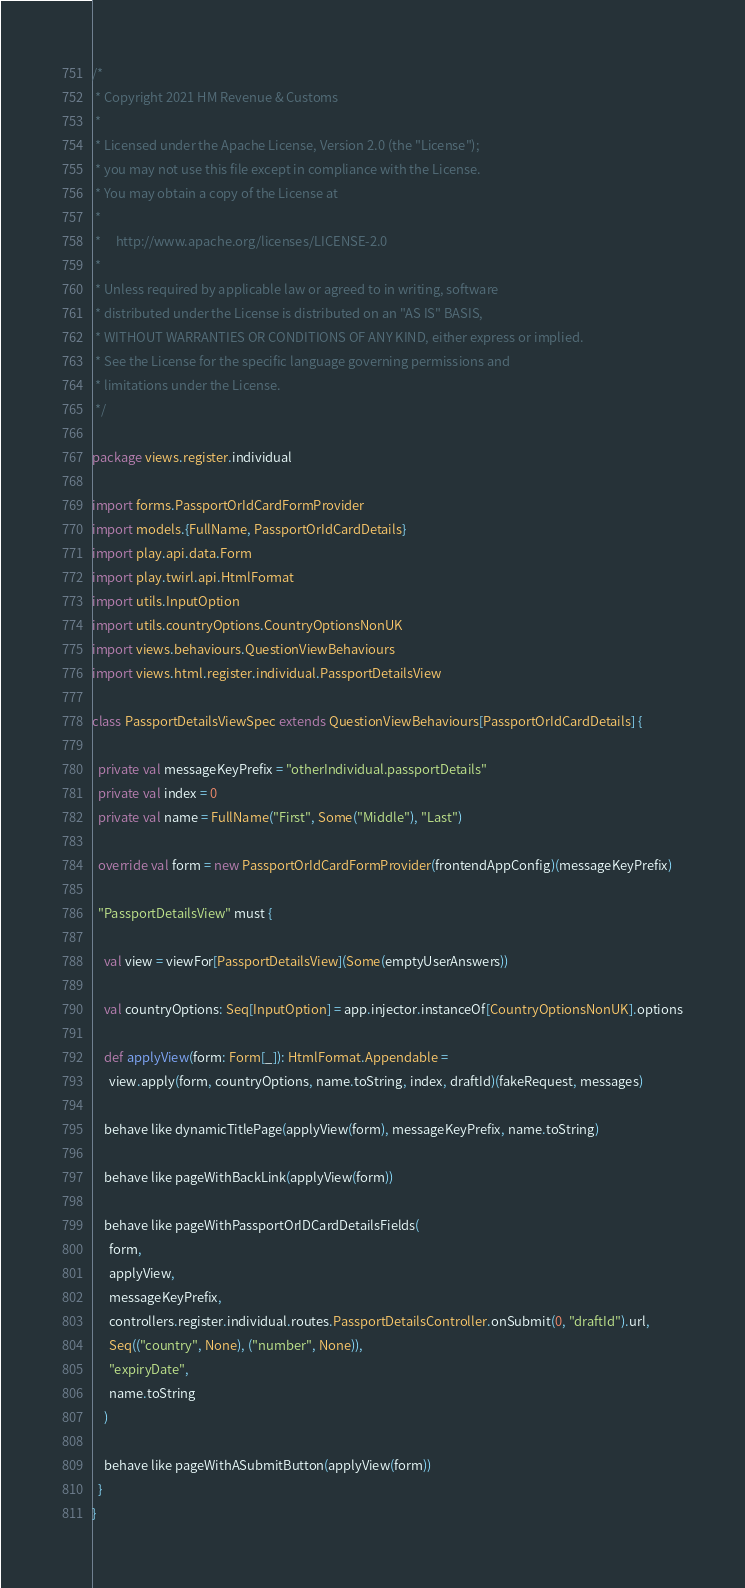<code> <loc_0><loc_0><loc_500><loc_500><_Scala_>/*
 * Copyright 2021 HM Revenue & Customs
 *
 * Licensed under the Apache License, Version 2.0 (the "License");
 * you may not use this file except in compliance with the License.
 * You may obtain a copy of the License at
 *
 *     http://www.apache.org/licenses/LICENSE-2.0
 *
 * Unless required by applicable law or agreed to in writing, software
 * distributed under the License is distributed on an "AS IS" BASIS,
 * WITHOUT WARRANTIES OR CONDITIONS OF ANY KIND, either express or implied.
 * See the License for the specific language governing permissions and
 * limitations under the License.
 */

package views.register.individual

import forms.PassportOrIdCardFormProvider
import models.{FullName, PassportOrIdCardDetails}
import play.api.data.Form
import play.twirl.api.HtmlFormat
import utils.InputOption
import utils.countryOptions.CountryOptionsNonUK
import views.behaviours.QuestionViewBehaviours
import views.html.register.individual.PassportDetailsView

class PassportDetailsViewSpec extends QuestionViewBehaviours[PassportOrIdCardDetails] {

  private val messageKeyPrefix = "otherIndividual.passportDetails"
  private val index = 0
  private val name = FullName("First", Some("Middle"), "Last")

  override val form = new PassportOrIdCardFormProvider(frontendAppConfig)(messageKeyPrefix)

  "PassportDetailsView" must {

    val view = viewFor[PassportDetailsView](Some(emptyUserAnswers))

    val countryOptions: Seq[InputOption] = app.injector.instanceOf[CountryOptionsNonUK].options

    def applyView(form: Form[_]): HtmlFormat.Appendable =
      view.apply(form, countryOptions, name.toString, index, draftId)(fakeRequest, messages)

    behave like dynamicTitlePage(applyView(form), messageKeyPrefix, name.toString)

    behave like pageWithBackLink(applyView(form))

    behave like pageWithPassportOrIDCardDetailsFields(
      form,
      applyView,
      messageKeyPrefix,
      controllers.register.individual.routes.PassportDetailsController.onSubmit(0, "draftId").url,
      Seq(("country", None), ("number", None)),
      "expiryDate",
      name.toString
    )

    behave like pageWithASubmitButton(applyView(form))
  }
}
</code> 